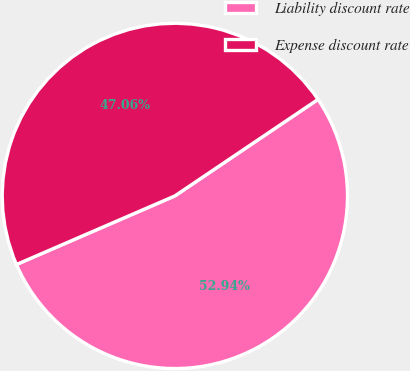Convert chart to OTSL. <chart><loc_0><loc_0><loc_500><loc_500><pie_chart><fcel>Liability discount rate<fcel>Expense discount rate<nl><fcel>52.94%<fcel>47.06%<nl></chart> 